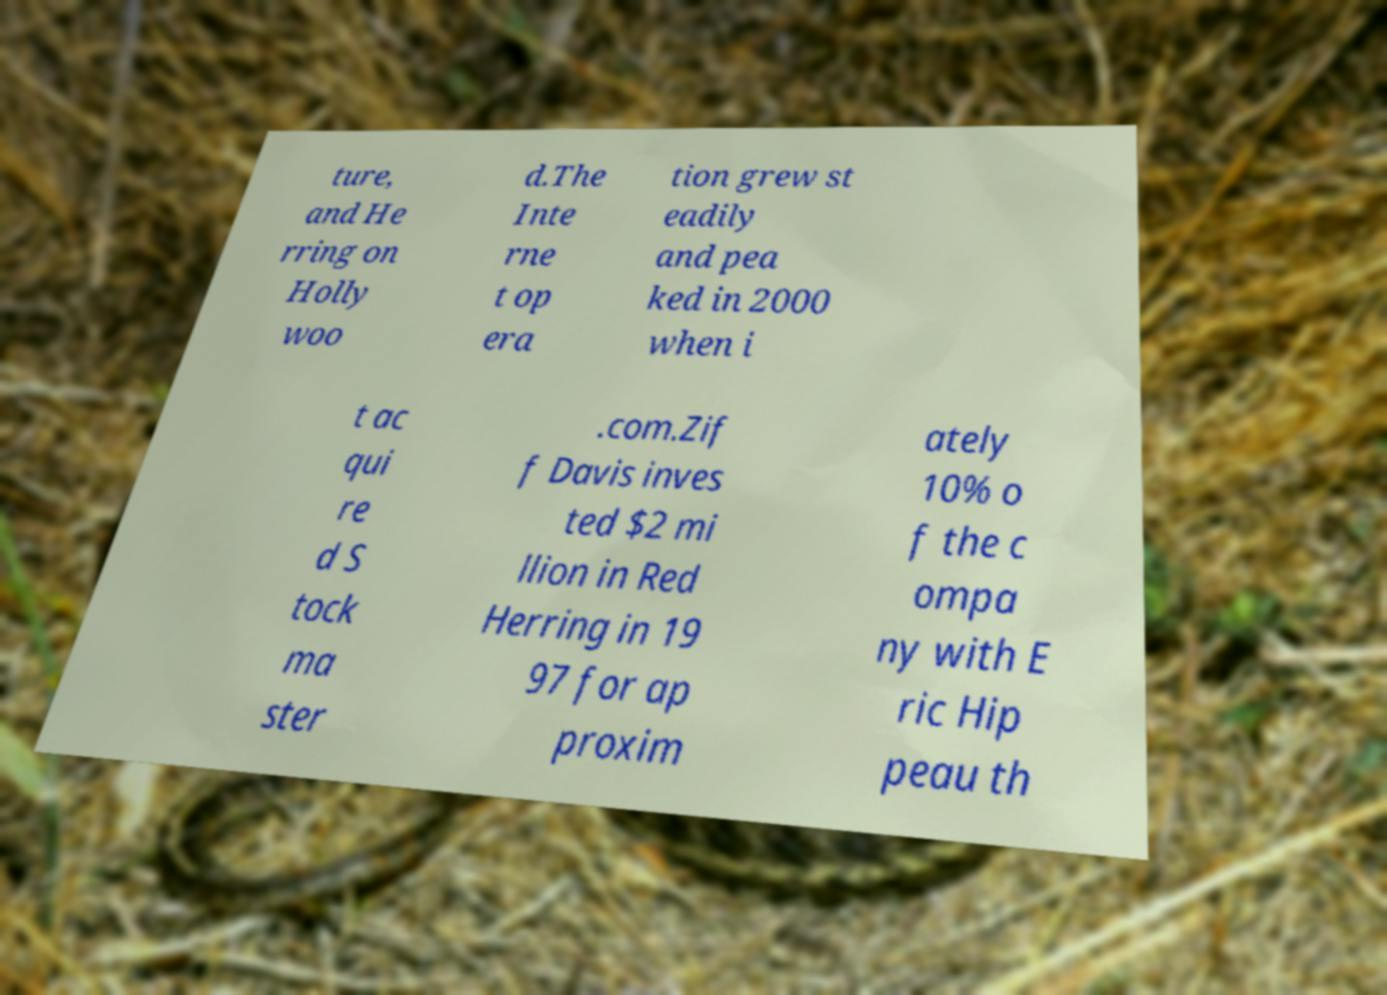For documentation purposes, I need the text within this image transcribed. Could you provide that? ture, and He rring on Holly woo d.The Inte rne t op era tion grew st eadily and pea ked in 2000 when i t ac qui re d S tock ma ster .com.Zif f Davis inves ted $2 mi llion in Red Herring in 19 97 for ap proxim ately 10% o f the c ompa ny with E ric Hip peau th 